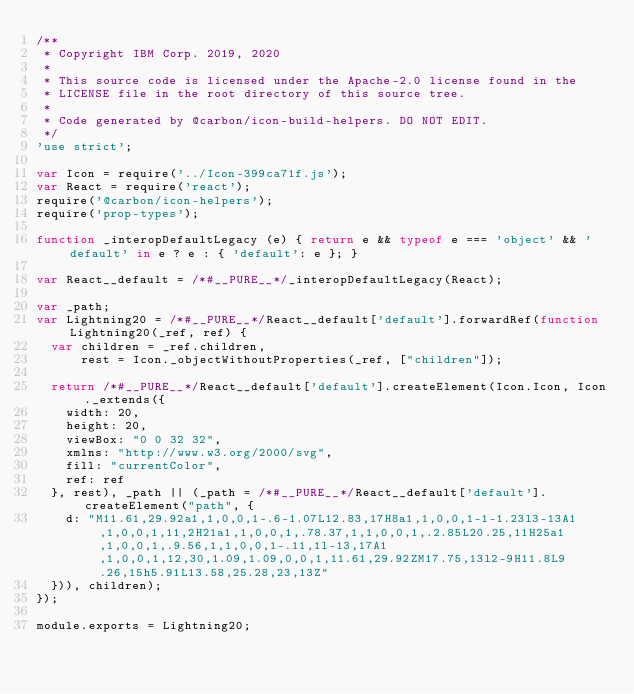<code> <loc_0><loc_0><loc_500><loc_500><_JavaScript_>/**
 * Copyright IBM Corp. 2019, 2020
 *
 * This source code is licensed under the Apache-2.0 license found in the
 * LICENSE file in the root directory of this source tree.
 *
 * Code generated by @carbon/icon-build-helpers. DO NOT EDIT.
 */
'use strict';

var Icon = require('../Icon-399ca71f.js');
var React = require('react');
require('@carbon/icon-helpers');
require('prop-types');

function _interopDefaultLegacy (e) { return e && typeof e === 'object' && 'default' in e ? e : { 'default': e }; }

var React__default = /*#__PURE__*/_interopDefaultLegacy(React);

var _path;
var Lightning20 = /*#__PURE__*/React__default['default'].forwardRef(function Lightning20(_ref, ref) {
  var children = _ref.children,
      rest = Icon._objectWithoutProperties(_ref, ["children"]);

  return /*#__PURE__*/React__default['default'].createElement(Icon.Icon, Icon._extends({
    width: 20,
    height: 20,
    viewBox: "0 0 32 32",
    xmlns: "http://www.w3.org/2000/svg",
    fill: "currentColor",
    ref: ref
  }, rest), _path || (_path = /*#__PURE__*/React__default['default'].createElement("path", {
    d: "M11.61,29.92a1,1,0,0,1-.6-1.07L12.83,17H8a1,1,0,0,1-1-1.23l3-13A1,1,0,0,1,11,2H21a1,1,0,0,1,.78.37,1,1,0,0,1,.2.85L20.25,11H25a1,1,0,0,1,.9.56,1,1,0,0,1-.11,1l-13,17A1,1,0,0,1,12,30,1.09,1.09,0,0,1,11.61,29.92ZM17.75,13l2-9H11.8L9.26,15h5.91L13.58,25.28,23,13Z"
  })), children);
});

module.exports = Lightning20;
</code> 